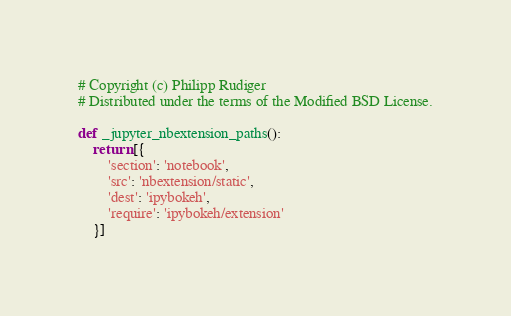Convert code to text. <code><loc_0><loc_0><loc_500><loc_500><_Python_>
# Copyright (c) Philipp Rudiger
# Distributed under the terms of the Modified BSD License.

def _jupyter_nbextension_paths():
    return [{
        'section': 'notebook',
        'src': 'nbextension/static',
        'dest': 'ipybokeh',
        'require': 'ipybokeh/extension'
    }]
</code> 